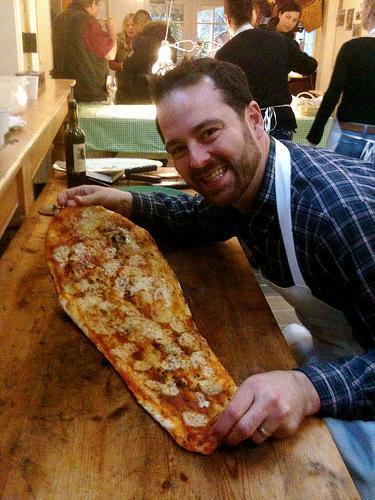How many rings is the man wearing?
Give a very brief answer. 1. 